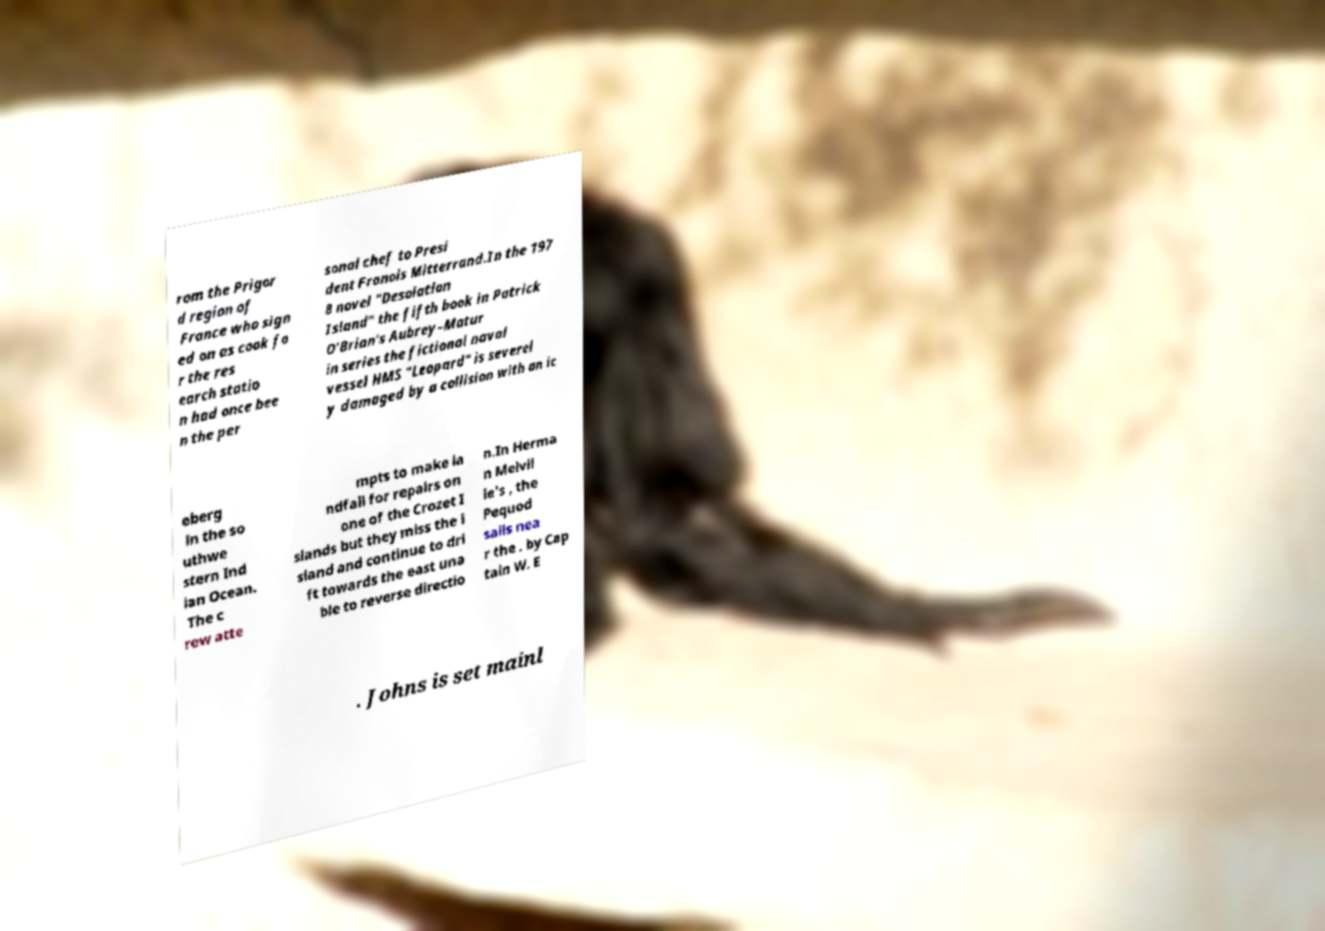Please read and relay the text visible in this image. What does it say? rom the Prigor d region of France who sign ed on as cook fo r the res earch statio n had once bee n the per sonal chef to Presi dent Franois Mitterrand.In the 197 8 novel "Desolation Island" the fifth book in Patrick O'Brian's Aubrey–Matur in series the fictional naval vessel HMS "Leopard" is severel y damaged by a collision with an ic eberg in the so uthwe stern Ind ian Ocean. The c rew atte mpts to make la ndfall for repairs on one of the Crozet I slands but they miss the i sland and continue to dri ft towards the east una ble to reverse directio n.In Herma n Melvil le's , the Pequod sails nea r the . by Cap tain W. E . Johns is set mainl 